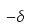<formula> <loc_0><loc_0><loc_500><loc_500>- \delta</formula> 